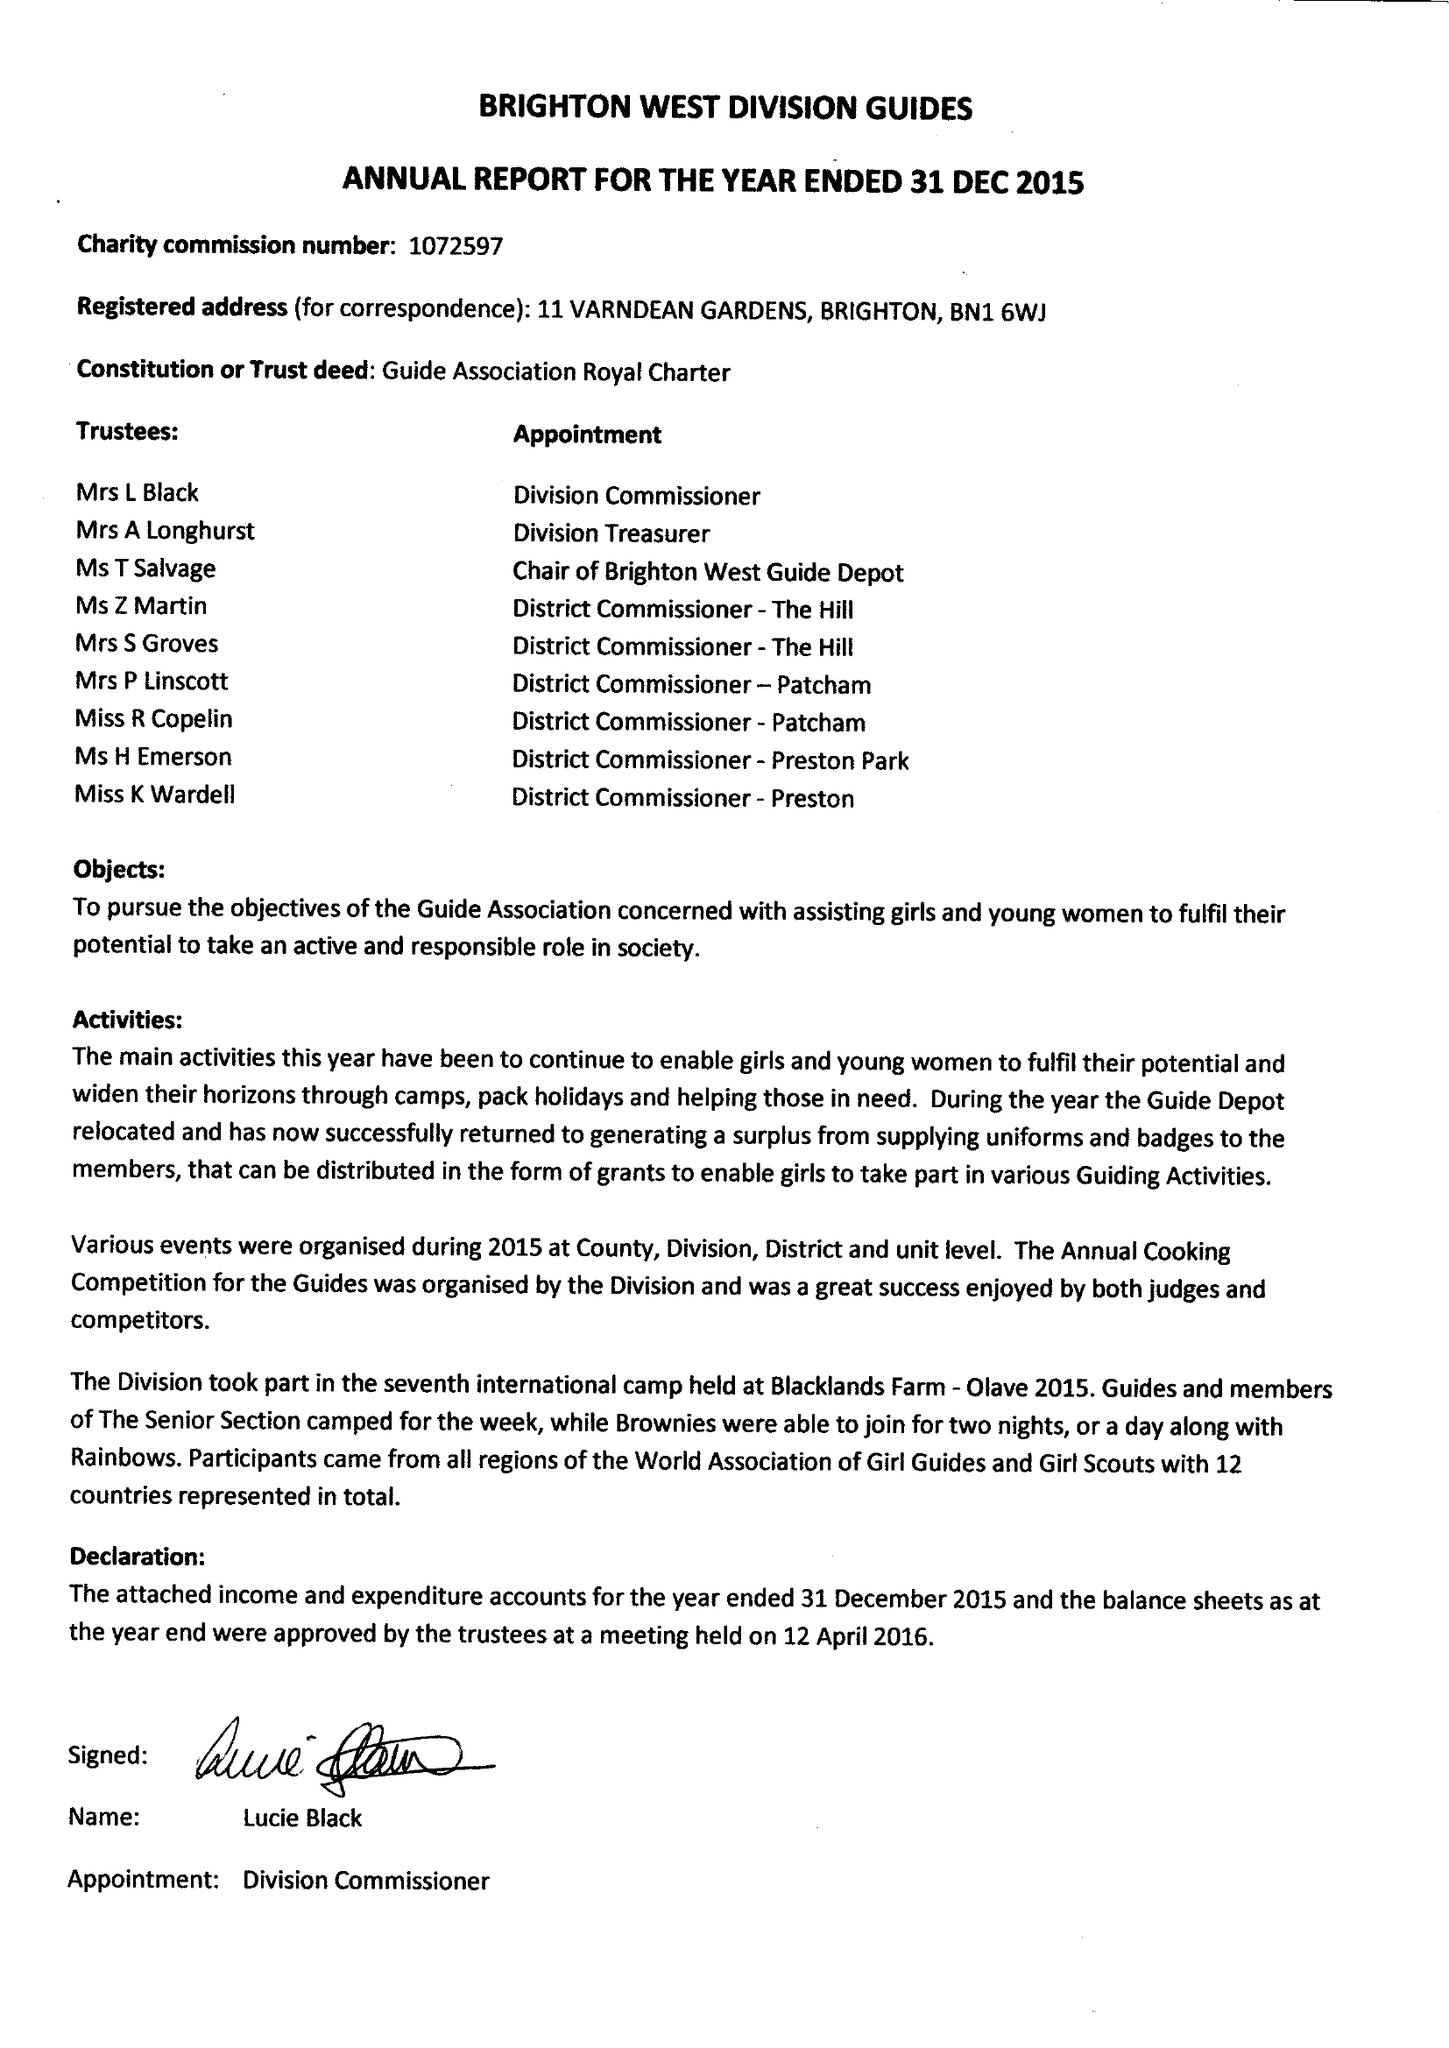What is the value for the address__post_town?
Answer the question using a single word or phrase. BRIGHTON 